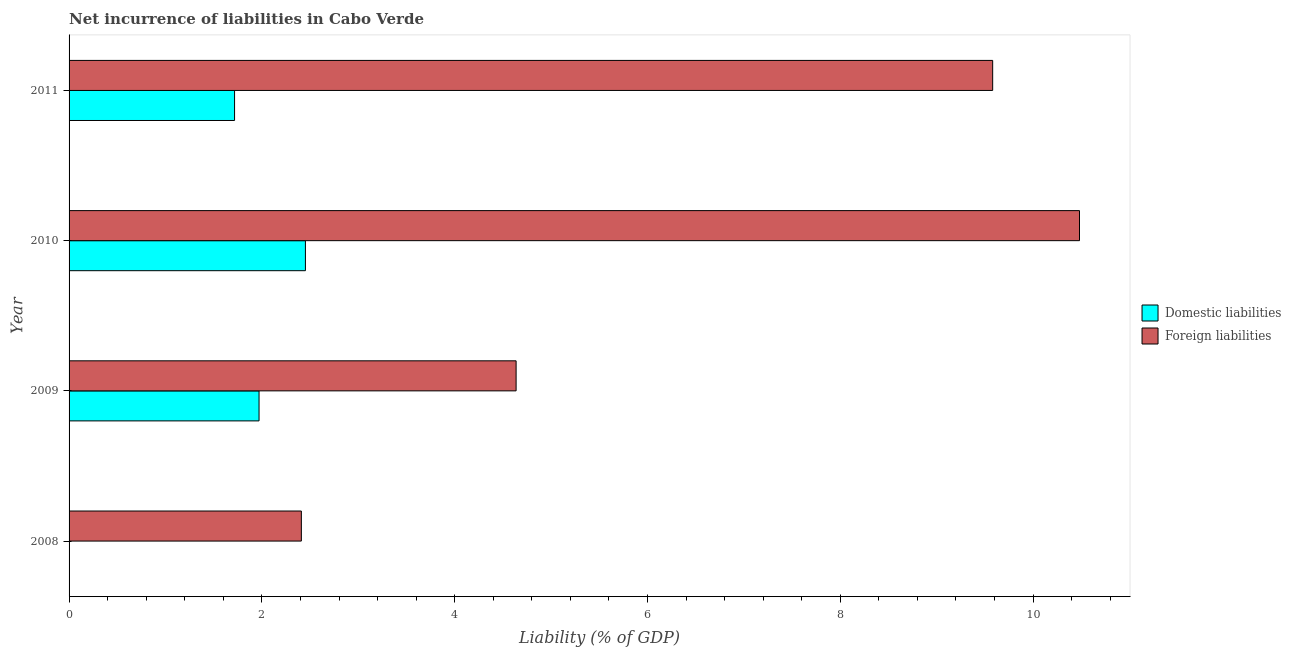Are the number of bars per tick equal to the number of legend labels?
Provide a succinct answer. No. Are the number of bars on each tick of the Y-axis equal?
Keep it short and to the point. No. How many bars are there on the 1st tick from the bottom?
Provide a succinct answer. 1. In how many cases, is the number of bars for a given year not equal to the number of legend labels?
Provide a succinct answer. 1. What is the incurrence of foreign liabilities in 2008?
Keep it short and to the point. 2.41. Across all years, what is the maximum incurrence of domestic liabilities?
Give a very brief answer. 2.45. Across all years, what is the minimum incurrence of domestic liabilities?
Keep it short and to the point. 0. In which year was the incurrence of foreign liabilities maximum?
Give a very brief answer. 2010. What is the total incurrence of domestic liabilities in the graph?
Offer a very short reply. 6.14. What is the difference between the incurrence of foreign liabilities in 2008 and that in 2009?
Offer a terse response. -2.23. What is the difference between the incurrence of foreign liabilities in 2011 and the incurrence of domestic liabilities in 2009?
Make the answer very short. 7.61. What is the average incurrence of domestic liabilities per year?
Make the answer very short. 1.53. In the year 2009, what is the difference between the incurrence of domestic liabilities and incurrence of foreign liabilities?
Ensure brevity in your answer.  -2.67. In how many years, is the incurrence of domestic liabilities greater than 3.6 %?
Offer a terse response. 0. What is the ratio of the incurrence of foreign liabilities in 2009 to that in 2011?
Provide a succinct answer. 0.48. What is the difference between the highest and the second highest incurrence of foreign liabilities?
Ensure brevity in your answer.  0.9. What is the difference between the highest and the lowest incurrence of foreign liabilities?
Provide a short and direct response. 8.07. Is the sum of the incurrence of foreign liabilities in 2010 and 2011 greater than the maximum incurrence of domestic liabilities across all years?
Your answer should be compact. Yes. How many bars are there?
Your answer should be very brief. 7. How many years are there in the graph?
Provide a succinct answer. 4. Are the values on the major ticks of X-axis written in scientific E-notation?
Ensure brevity in your answer.  No. Does the graph contain any zero values?
Keep it short and to the point. Yes. Does the graph contain grids?
Make the answer very short. No. How are the legend labels stacked?
Provide a succinct answer. Vertical. What is the title of the graph?
Your answer should be compact. Net incurrence of liabilities in Cabo Verde. Does "Tetanus" appear as one of the legend labels in the graph?
Your response must be concise. No. What is the label or title of the X-axis?
Provide a short and direct response. Liability (% of GDP). What is the Liability (% of GDP) in Foreign liabilities in 2008?
Offer a terse response. 2.41. What is the Liability (% of GDP) of Domestic liabilities in 2009?
Make the answer very short. 1.97. What is the Liability (% of GDP) in Foreign liabilities in 2009?
Make the answer very short. 4.64. What is the Liability (% of GDP) in Domestic liabilities in 2010?
Give a very brief answer. 2.45. What is the Liability (% of GDP) in Foreign liabilities in 2010?
Keep it short and to the point. 10.48. What is the Liability (% of GDP) in Domestic liabilities in 2011?
Provide a succinct answer. 1.72. What is the Liability (% of GDP) of Foreign liabilities in 2011?
Provide a succinct answer. 9.58. Across all years, what is the maximum Liability (% of GDP) in Domestic liabilities?
Provide a succinct answer. 2.45. Across all years, what is the maximum Liability (% of GDP) of Foreign liabilities?
Your answer should be compact. 10.48. Across all years, what is the minimum Liability (% of GDP) in Domestic liabilities?
Your response must be concise. 0. Across all years, what is the minimum Liability (% of GDP) of Foreign liabilities?
Your answer should be compact. 2.41. What is the total Liability (% of GDP) of Domestic liabilities in the graph?
Your answer should be compact. 6.14. What is the total Liability (% of GDP) of Foreign liabilities in the graph?
Make the answer very short. 27.11. What is the difference between the Liability (% of GDP) in Foreign liabilities in 2008 and that in 2009?
Ensure brevity in your answer.  -2.23. What is the difference between the Liability (% of GDP) of Foreign liabilities in 2008 and that in 2010?
Your response must be concise. -8.07. What is the difference between the Liability (% of GDP) in Foreign liabilities in 2008 and that in 2011?
Your answer should be compact. -7.17. What is the difference between the Liability (% of GDP) of Domestic liabilities in 2009 and that in 2010?
Keep it short and to the point. -0.48. What is the difference between the Liability (% of GDP) of Foreign liabilities in 2009 and that in 2010?
Provide a short and direct response. -5.84. What is the difference between the Liability (% of GDP) of Domestic liabilities in 2009 and that in 2011?
Your answer should be compact. 0.25. What is the difference between the Liability (% of GDP) of Foreign liabilities in 2009 and that in 2011?
Give a very brief answer. -4.94. What is the difference between the Liability (% of GDP) in Domestic liabilities in 2010 and that in 2011?
Make the answer very short. 0.74. What is the difference between the Liability (% of GDP) of Foreign liabilities in 2010 and that in 2011?
Your answer should be very brief. 0.9. What is the difference between the Liability (% of GDP) in Domestic liabilities in 2009 and the Liability (% of GDP) in Foreign liabilities in 2010?
Your answer should be very brief. -8.51. What is the difference between the Liability (% of GDP) in Domestic liabilities in 2009 and the Liability (% of GDP) in Foreign liabilities in 2011?
Give a very brief answer. -7.61. What is the difference between the Liability (% of GDP) of Domestic liabilities in 2010 and the Liability (% of GDP) of Foreign liabilities in 2011?
Your answer should be compact. -7.13. What is the average Liability (% of GDP) in Domestic liabilities per year?
Your answer should be very brief. 1.53. What is the average Liability (% of GDP) in Foreign liabilities per year?
Offer a terse response. 6.78. In the year 2009, what is the difference between the Liability (% of GDP) of Domestic liabilities and Liability (% of GDP) of Foreign liabilities?
Offer a very short reply. -2.67. In the year 2010, what is the difference between the Liability (% of GDP) in Domestic liabilities and Liability (% of GDP) in Foreign liabilities?
Offer a very short reply. -8.03. In the year 2011, what is the difference between the Liability (% of GDP) of Domestic liabilities and Liability (% of GDP) of Foreign liabilities?
Your answer should be very brief. -7.86. What is the ratio of the Liability (% of GDP) of Foreign liabilities in 2008 to that in 2009?
Ensure brevity in your answer.  0.52. What is the ratio of the Liability (% of GDP) in Foreign liabilities in 2008 to that in 2010?
Give a very brief answer. 0.23. What is the ratio of the Liability (% of GDP) of Foreign liabilities in 2008 to that in 2011?
Offer a very short reply. 0.25. What is the ratio of the Liability (% of GDP) in Domestic liabilities in 2009 to that in 2010?
Keep it short and to the point. 0.8. What is the ratio of the Liability (% of GDP) of Foreign liabilities in 2009 to that in 2010?
Ensure brevity in your answer.  0.44. What is the ratio of the Liability (% of GDP) of Domestic liabilities in 2009 to that in 2011?
Your answer should be very brief. 1.15. What is the ratio of the Liability (% of GDP) of Foreign liabilities in 2009 to that in 2011?
Offer a very short reply. 0.48. What is the ratio of the Liability (% of GDP) in Domestic liabilities in 2010 to that in 2011?
Your answer should be very brief. 1.43. What is the ratio of the Liability (% of GDP) in Foreign liabilities in 2010 to that in 2011?
Ensure brevity in your answer.  1.09. What is the difference between the highest and the second highest Liability (% of GDP) in Domestic liabilities?
Offer a terse response. 0.48. What is the difference between the highest and the second highest Liability (% of GDP) of Foreign liabilities?
Keep it short and to the point. 0.9. What is the difference between the highest and the lowest Liability (% of GDP) of Domestic liabilities?
Your answer should be compact. 2.45. What is the difference between the highest and the lowest Liability (% of GDP) in Foreign liabilities?
Give a very brief answer. 8.07. 